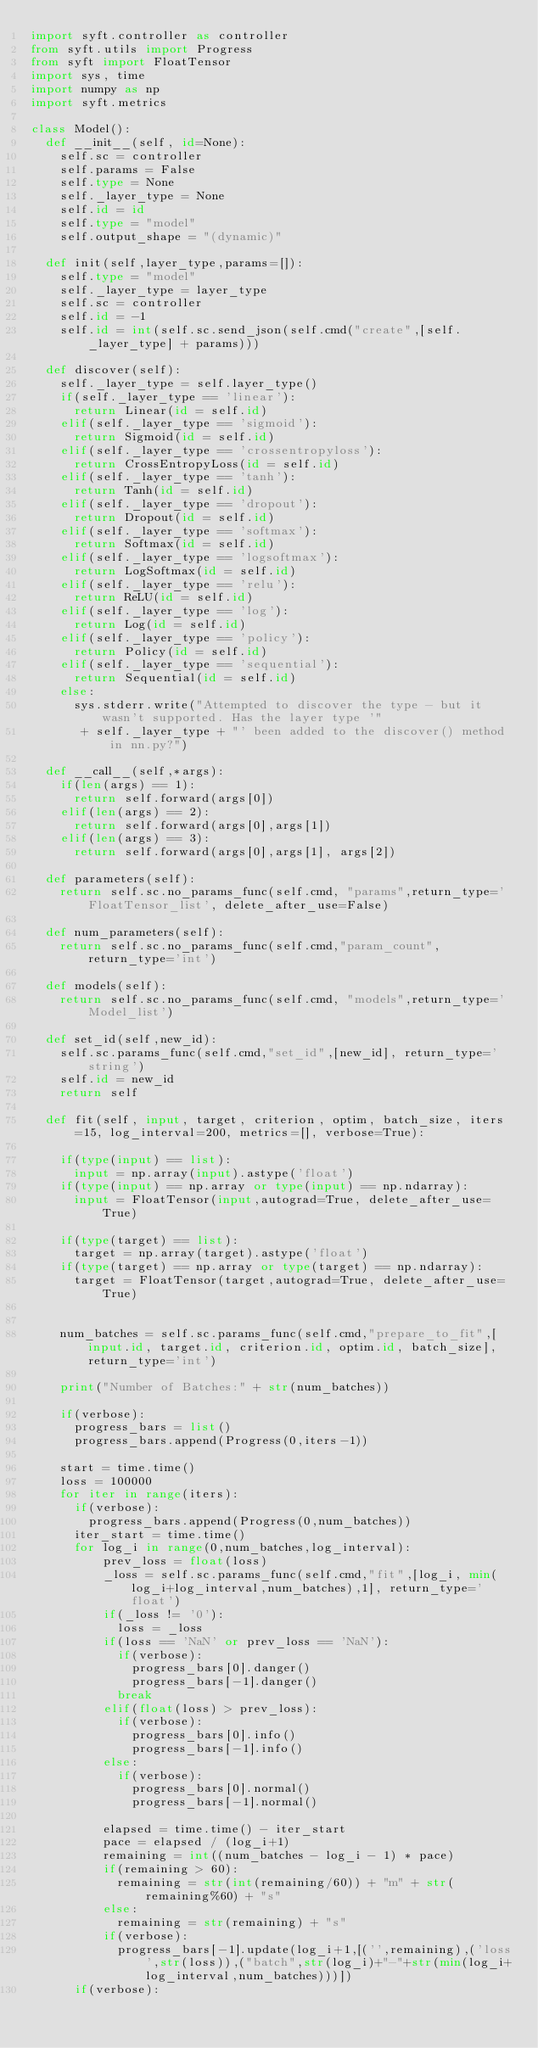<code> <loc_0><loc_0><loc_500><loc_500><_Python_>import syft.controller as controller
from syft.utils import Progress
from syft import FloatTensor
import sys, time
import numpy as np
import syft.metrics

class Model():
	def __init__(self, id=None):
		self.sc = controller
		self.params = False
		self.type = None
		self._layer_type = None
		self.id = id
		self.type = "model"
		self.output_shape = "(dynamic)"

	def init(self,layer_type,params=[]):
		self.type = "model"
		self._layer_type = layer_type
		self.sc = controller
		self.id = -1
		self.id = int(self.sc.send_json(self.cmd("create",[self._layer_type] + params)))

	def discover(self):
		self._layer_type = self.layer_type()
		if(self._layer_type == 'linear'):
			return Linear(id = self.id)
		elif(self._layer_type == 'sigmoid'):
			return Sigmoid(id = self.id)
		elif(self._layer_type == 'crossentropyloss'):
			return CrossEntropyLoss(id = self.id)
		elif(self._layer_type == 'tanh'):
			return Tanh(id = self.id)
		elif(self._layer_type == 'dropout'):
			return Dropout(id = self.id)
		elif(self._layer_type == 'softmax'):
			return Softmax(id = self.id)
		elif(self._layer_type == 'logsoftmax'):
			return LogSoftmax(id = self.id)
		elif(self._layer_type == 'relu'):
			return ReLU(id = self.id)
		elif(self._layer_type == 'log'):
			return Log(id = self.id)
		elif(self._layer_type == 'policy'):
			return Policy(id = self.id)
		elif(self._layer_type == 'sequential'):
			return Sequential(id = self.id)
		else:
			sys.stderr.write("Attempted to discover the type - but it wasn't supported. Has the layer type '"
			 + self._layer_type + "' been added to the discover() method in nn.py?")

	def __call__(self,*args):
		if(len(args) == 1):
			return self.forward(args[0])
		elif(len(args) == 2):
			return self.forward(args[0],args[1])
		elif(len(args) == 3):
			return self.forward(args[0],args[1], args[2])

	def parameters(self):
		return self.sc.no_params_func(self.cmd, "params",return_type='FloatTensor_list', delete_after_use=False)

	def num_parameters(self):
		return self.sc.no_params_func(self.cmd,"param_count",return_type='int')

	def models(self):
		return self.sc.no_params_func(self.cmd, "models",return_type='Model_list')

	def set_id(self,new_id):
		self.sc.params_func(self.cmd,"set_id",[new_id], return_type='string')
		self.id = new_id
		return self

	def fit(self, input, target, criterion, optim, batch_size, iters=15, log_interval=200, metrics=[], verbose=True):

		if(type(input) == list):
			input = np.array(input).astype('float')
		if(type(input) == np.array or type(input) == np.ndarray):
			input = FloatTensor(input,autograd=True, delete_after_use=True)

		if(type(target) == list):
			target = np.array(target).astype('float')
		if(type(target) == np.array or type(target) == np.ndarray):
			target = FloatTensor(target,autograd=True, delete_after_use=True)


		num_batches = self.sc.params_func(self.cmd,"prepare_to_fit",[input.id, target.id, criterion.id, optim.id, batch_size], return_type='int')

		print("Number of Batches:" + str(num_batches))

		if(verbose):
			progress_bars = list()
			progress_bars.append(Progress(0,iters-1))

		start = time.time()
		loss = 100000
		for iter in range(iters):
			if(verbose):
				progress_bars.append(Progress(0,num_batches))
			iter_start = time.time()
			for log_i in range(0,num_batches,log_interval):
					prev_loss = float(loss)
					_loss = self.sc.params_func(self.cmd,"fit",[log_i, min(log_i+log_interval,num_batches),1], return_type='float')
					if(_loss != '0'):
						loss = _loss
					if(loss == 'NaN' or prev_loss == 'NaN'):
						if(verbose):
							progress_bars[0].danger()
							progress_bars[-1].danger()	
						break
					elif(float(loss) > prev_loss):
						if(verbose):
							progress_bars[0].info()	
							progress_bars[-1].info()	
					else:
						if(verbose):
							progress_bars[0].normal()
							progress_bars[-1].normal()

					elapsed = time.time() - iter_start
					pace = elapsed / (log_i+1)
					remaining = int((num_batches - log_i - 1) * pace)
					if(remaining > 60):
						remaining = str(int(remaining/60)) + "m" + str(remaining%60) + "s"
					else:
						remaining = str(remaining) + "s"
					if(verbose):
						progress_bars[-1].update(log_i+1,[('',remaining),('loss',str(loss)),("batch",str(log_i)+"-"+str(min(log_i+log_interval,num_batches)))])
			if(verbose):</code> 